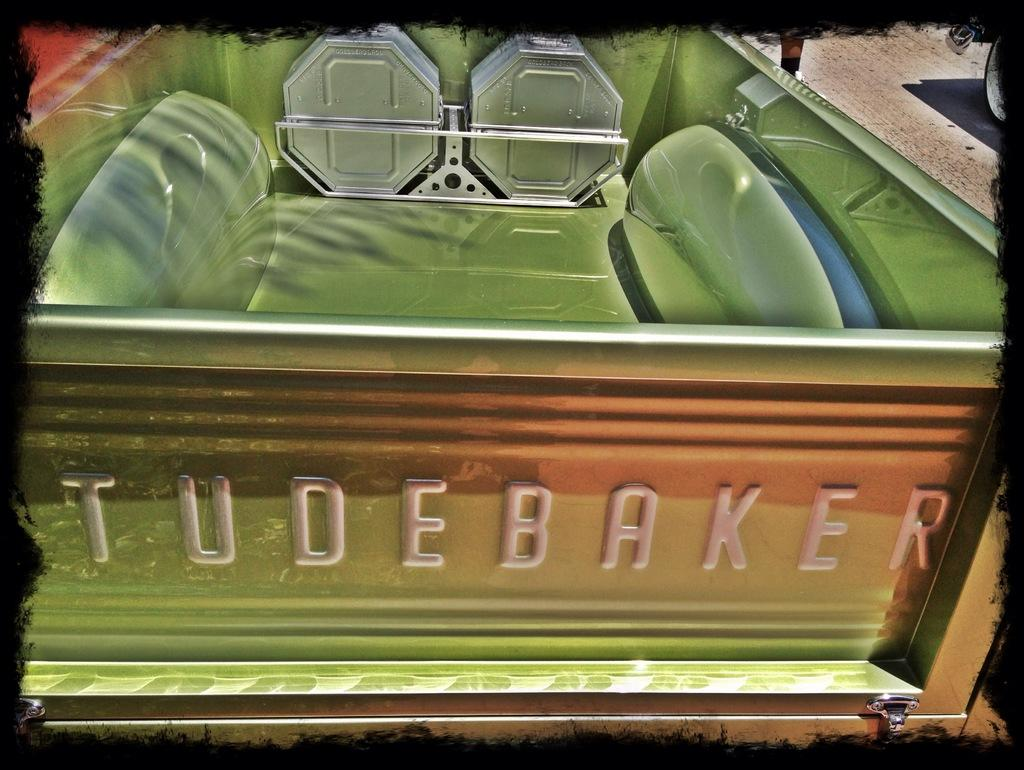What is the main subject in the image? There is a vehicle in the image. Can you describe any part of a person in the image? A person's leg is visible in the image. What is on the ground near the vehicle? There is a wheel on the ground in the image. How was the image altered or modified? The image has an edited frame. What type of mitten is the person wearing in the image? There is no mitten visible in the image; only a person's leg is shown. How many rocks can be seen in the image? There is no rock present in the image. 